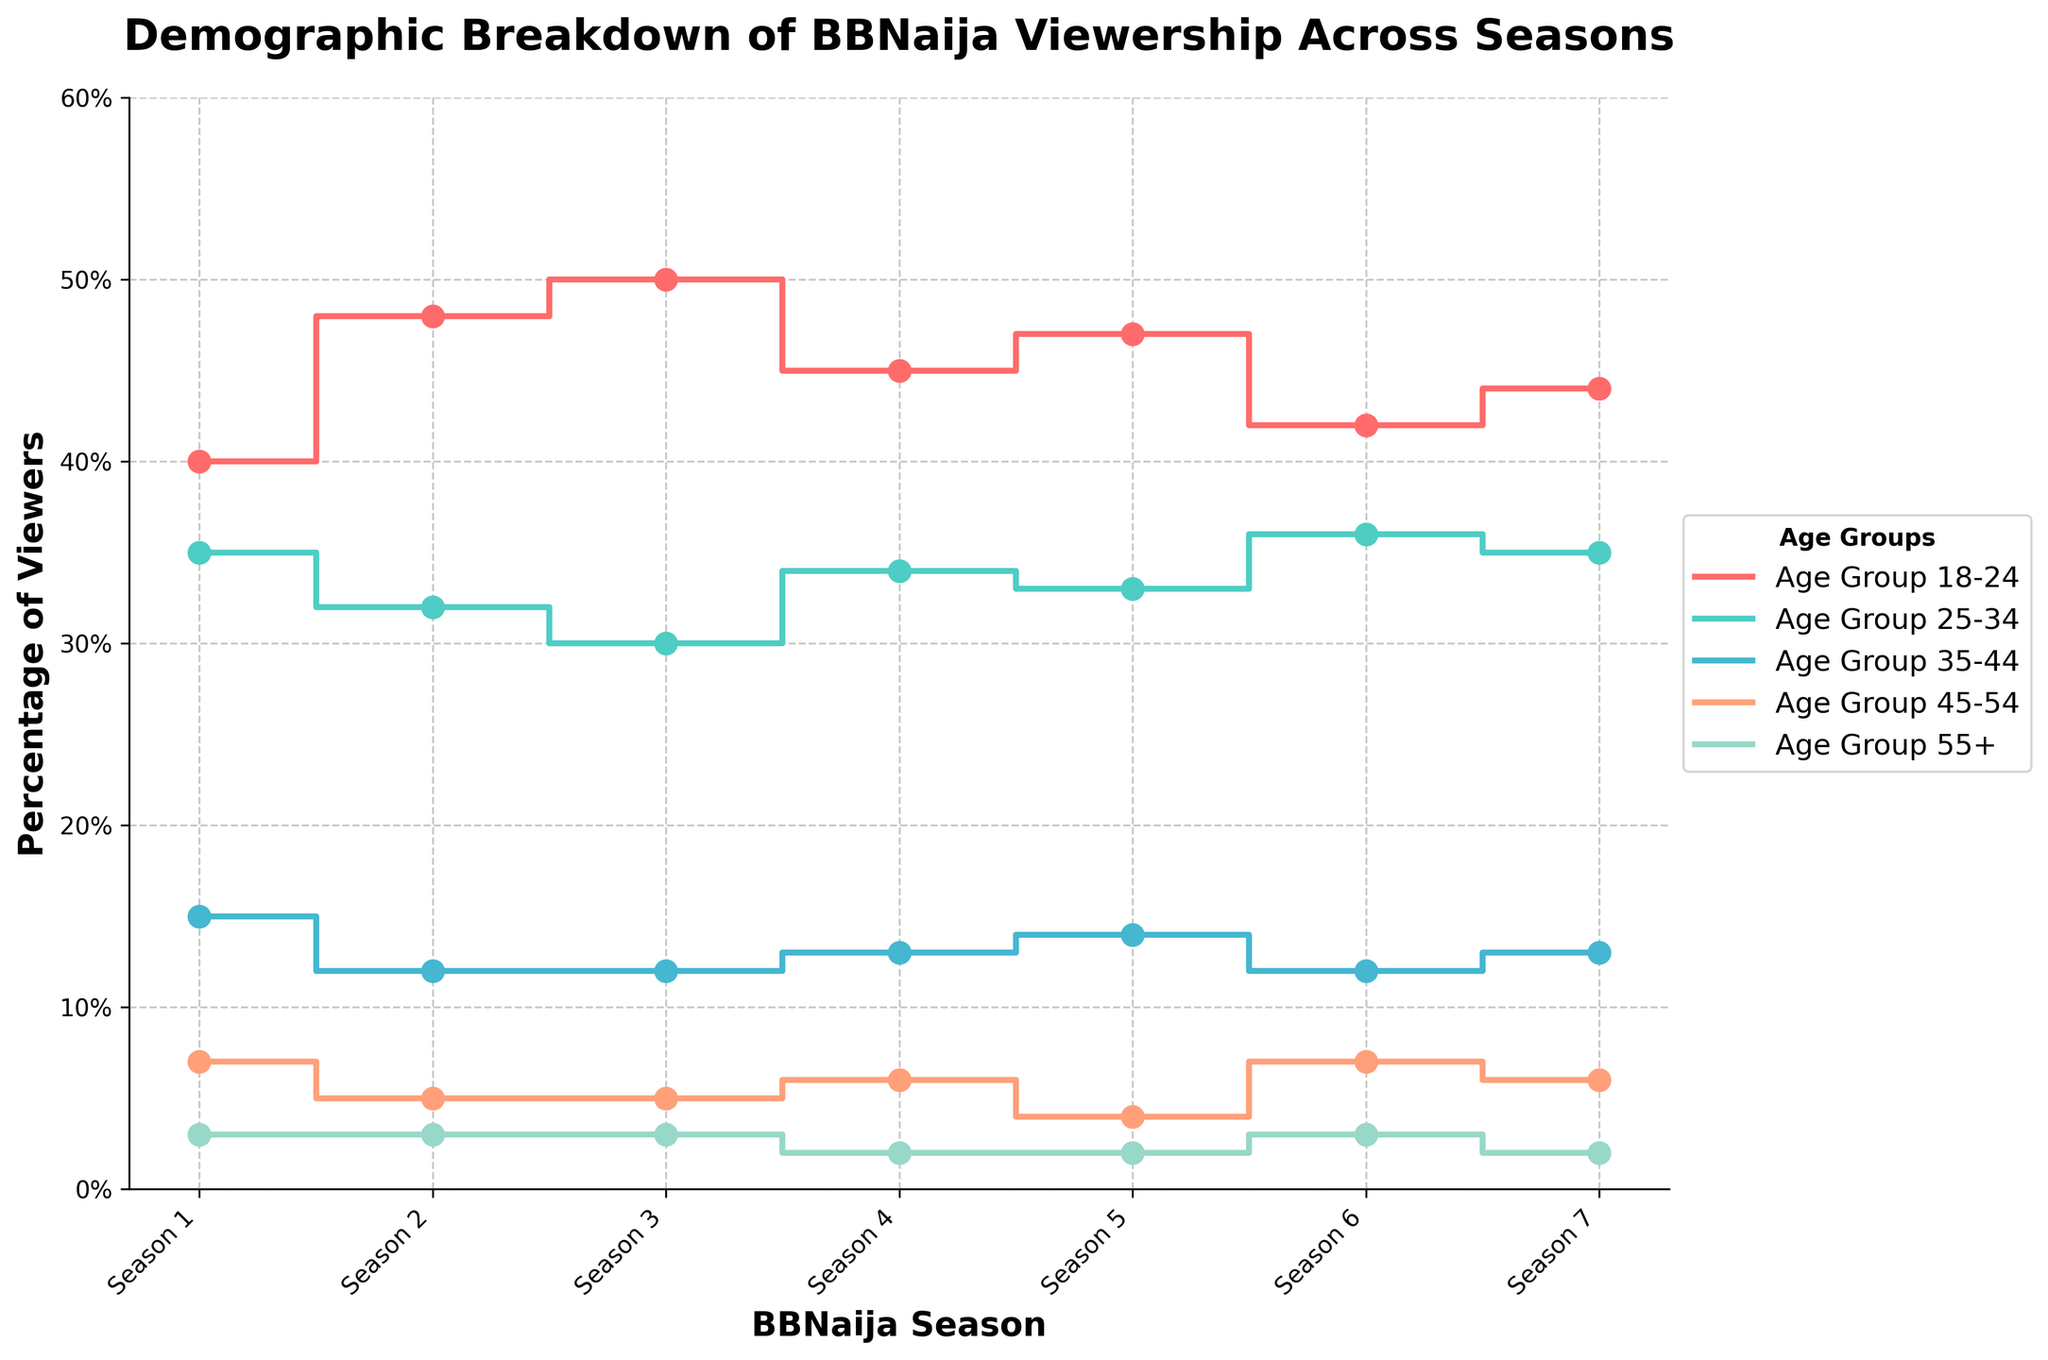What is the title of the plot? The title is typically displayed at the top of the figure. In this case, it is clearly labeled in bold text at the top of the plot.
Answer: Demographic Breakdown of BBNaija Viewership Across Seasons How many seasons are depicted in the plot? The x-axis of the plot represents the seasons. By counting the unique labels on this axis, we can determine the number of seasons shown.
Answer: 7 Which age group had the highest viewership in Season 3? To find this, locate the data points for Season 3 across the different lines (each representing an age group) and identify the highest percentage.
Answer: Age Group 18-24 What is the percentage difference in viewership for Age Group 25-34 between Season 1 and Season 6? Look for the values corresponding to Age Group 25-34 for both Season 1 (35%) and Season 6 (36%). Subtract the former value from the latter to get the difference.
Answer: 1% Which age group shows the least variation in viewership percentages across all seasons? To determine this, compare the ranges (max - min) of the viewership percentages for each age group across all seasons. The group with the smallest range has the least variation.
Answer: Age Group 55+ Is there any age group that consistently increased or decreased its viewership across all seasons? To answer this, visually inspect each age group's trend line to see if it consistently trends upward or downward across all seven seasons.
Answer: No How does the viewership for Age Group 45-54 change from Season 5 to Season 6? Check the specific data points on the plot for Age Group 45-54 for Seasons 5 (4%) and 6 (7%) and calculate the change.
Answer: Increased by 3% Which two age groups have nearly equal viewership percentages in Season 7? Find and compare the data points for Season 7 across all age groups. Identify the two groups with the closest percentages.
Answer: Age Group 25-34 and Age Group 35-44 What trend can be observed for Age Group 18-24 from Seasons 1 to 3? Observe the line representing Age Group 18-24 from Season 1 through to Season 3 and note the direction of its movement.
Answer: Increasing trend What is the average viewership percentage for Age Group 35-44 across all seasons? Sum the percentages for Age Group 35-44 for all seven seasons, then divide by the number of seasons (7) to find the average. \( \frac{15 + 12 + 12 + 13 + 14 + 12 + 13}{7} = \frac{91}{7} \approx 13% \)
Answer: 13% 